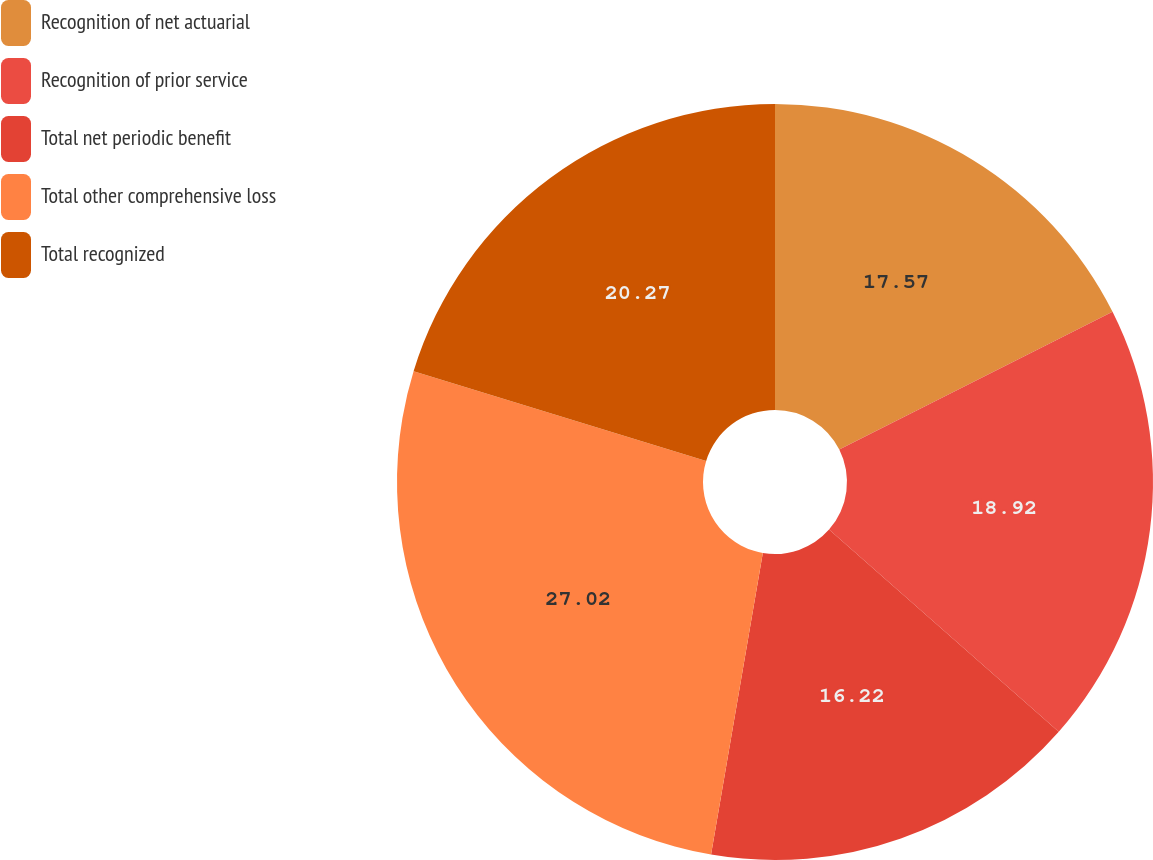Convert chart to OTSL. <chart><loc_0><loc_0><loc_500><loc_500><pie_chart><fcel>Recognition of net actuarial<fcel>Recognition of prior service<fcel>Total net periodic benefit<fcel>Total other comprehensive loss<fcel>Total recognized<nl><fcel>17.57%<fcel>18.92%<fcel>16.22%<fcel>27.03%<fcel>20.27%<nl></chart> 